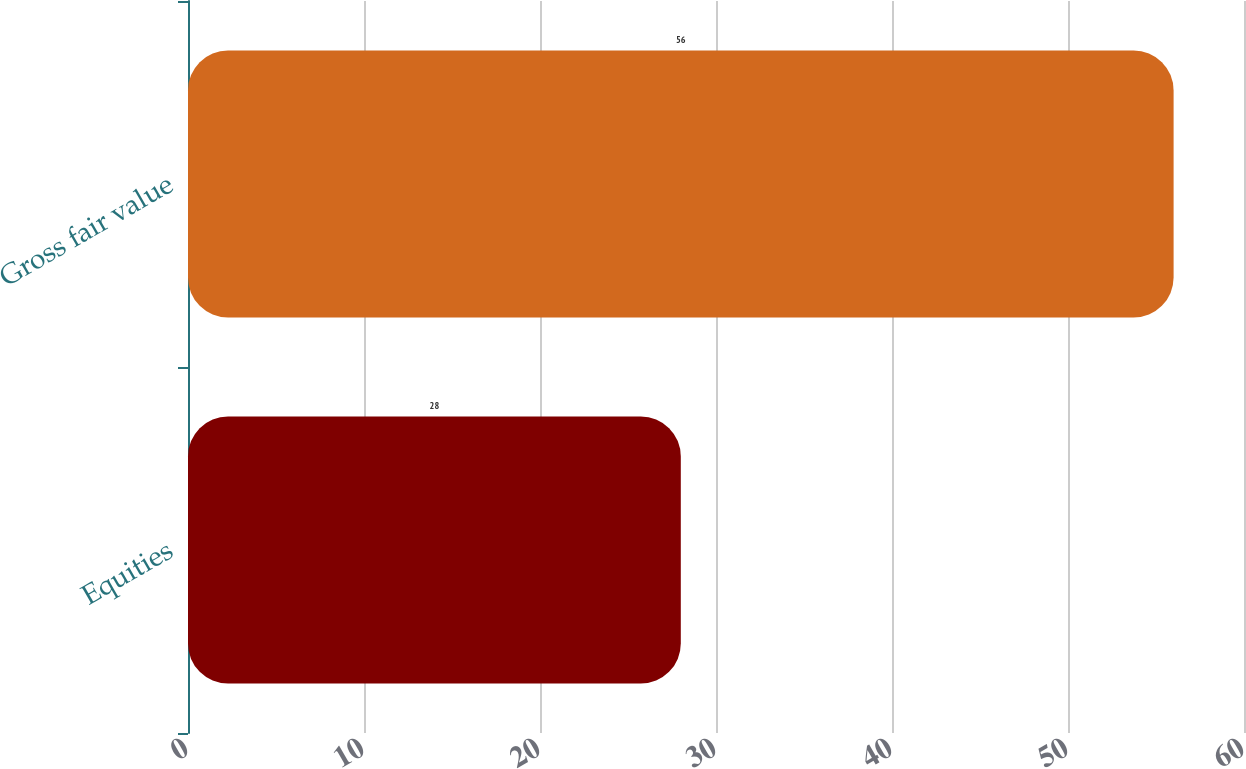Convert chart to OTSL. <chart><loc_0><loc_0><loc_500><loc_500><bar_chart><fcel>Equities<fcel>Gross fair value<nl><fcel>28<fcel>56<nl></chart> 